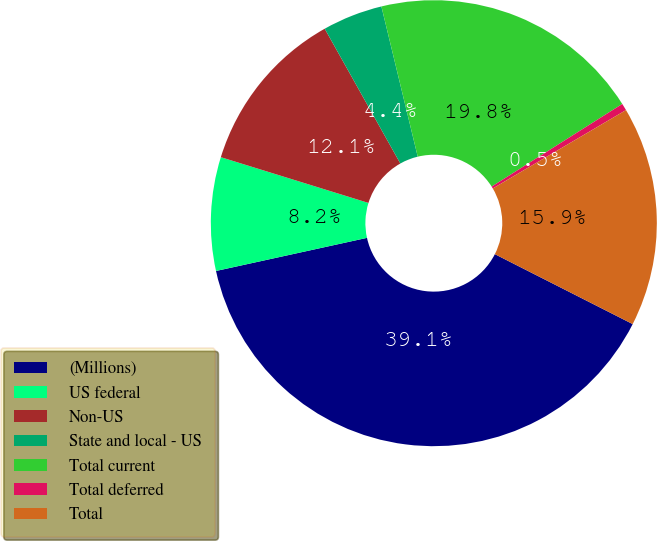<chart> <loc_0><loc_0><loc_500><loc_500><pie_chart><fcel>(Millions)<fcel>US federal<fcel>Non-US<fcel>State and local - US<fcel>Total current<fcel>Total deferred<fcel>Total<nl><fcel>39.09%<fcel>8.22%<fcel>12.08%<fcel>4.36%<fcel>19.8%<fcel>0.51%<fcel>15.94%<nl></chart> 